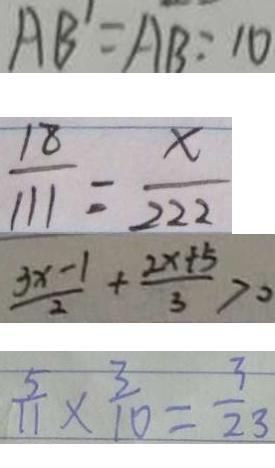Convert formula to latex. <formula><loc_0><loc_0><loc_500><loc_500>A B ^ { \prime } = A B = 1 0 
 \frac { 1 8 } { 1 1 1 } = \frac { x } { 2 2 2 } 
 \frac { 3 x - 1 } { 2 } + \frac { 2 x + 5 } { 3 } > 0 
 \frac { 5 } { 1 1 } \times \frac { 3 } { 1 0 } = \frac { 3 } { 2 3 }</formula> 